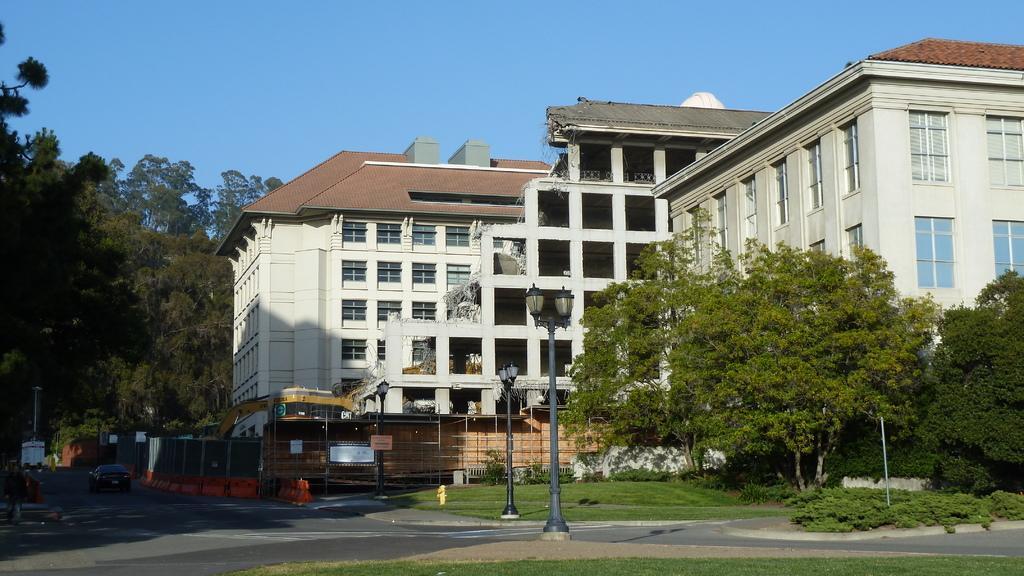In one or two sentences, can you explain what this image depicts? In this picture I can see road, poles, lights, grass, plants, trees, vehicles,fire hydrant, buildings, and in the background there is sky. 